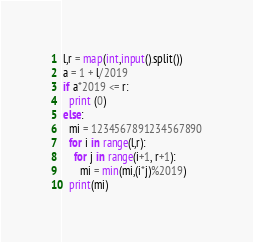Convert code to text. <code><loc_0><loc_0><loc_500><loc_500><_Python_>l,r = map(int,input().split())
a = 1 + l/2019
if a*2019 <= r:
  print (0)
else:
  mi = 1234567891234567890
  for i in range(l,r):
    for j in range(i+1, r+1):
      mi = min(mi,(i*j)%2019)
  print(mi)</code> 